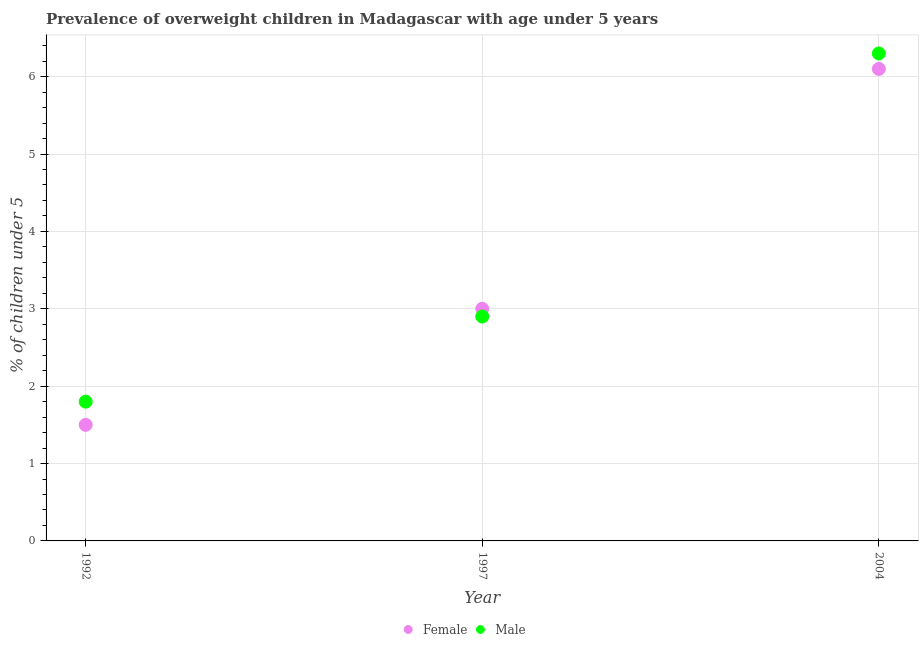How many different coloured dotlines are there?
Ensure brevity in your answer.  2. Is the number of dotlines equal to the number of legend labels?
Provide a short and direct response. Yes. What is the percentage of obese male children in 1997?
Give a very brief answer. 2.9. Across all years, what is the maximum percentage of obese female children?
Make the answer very short. 6.1. Across all years, what is the minimum percentage of obese female children?
Your response must be concise. 1.5. In which year was the percentage of obese male children minimum?
Give a very brief answer. 1992. What is the total percentage of obese male children in the graph?
Give a very brief answer. 11. What is the difference between the percentage of obese male children in 1992 and that in 2004?
Keep it short and to the point. -4.5. What is the difference between the percentage of obese male children in 1997 and the percentage of obese female children in 1992?
Ensure brevity in your answer.  1.4. What is the average percentage of obese female children per year?
Make the answer very short. 3.53. In the year 1992, what is the difference between the percentage of obese female children and percentage of obese male children?
Give a very brief answer. -0.3. What is the ratio of the percentage of obese female children in 1992 to that in 2004?
Keep it short and to the point. 0.25. Is the percentage of obese male children in 1992 less than that in 1997?
Offer a terse response. Yes. Is the difference between the percentage of obese female children in 1992 and 2004 greater than the difference between the percentage of obese male children in 1992 and 2004?
Your answer should be compact. No. What is the difference between the highest and the second highest percentage of obese male children?
Your answer should be very brief. 3.4. What is the difference between the highest and the lowest percentage of obese female children?
Offer a terse response. 4.6. In how many years, is the percentage of obese male children greater than the average percentage of obese male children taken over all years?
Your answer should be compact. 1. Does the percentage of obese male children monotonically increase over the years?
Make the answer very short. Yes. How many dotlines are there?
Provide a short and direct response. 2. Are the values on the major ticks of Y-axis written in scientific E-notation?
Your answer should be very brief. No. Does the graph contain any zero values?
Offer a very short reply. No. Does the graph contain grids?
Ensure brevity in your answer.  Yes. How are the legend labels stacked?
Offer a very short reply. Horizontal. What is the title of the graph?
Ensure brevity in your answer.  Prevalence of overweight children in Madagascar with age under 5 years. Does "International Visitors" appear as one of the legend labels in the graph?
Provide a succinct answer. No. What is the label or title of the Y-axis?
Make the answer very short.  % of children under 5. What is the  % of children under 5 of Male in 1992?
Give a very brief answer. 1.8. What is the  % of children under 5 of Female in 1997?
Provide a short and direct response. 3. What is the  % of children under 5 of Male in 1997?
Your answer should be compact. 2.9. What is the  % of children under 5 of Female in 2004?
Your answer should be very brief. 6.1. What is the  % of children under 5 of Male in 2004?
Your response must be concise. 6.3. Across all years, what is the maximum  % of children under 5 of Female?
Give a very brief answer. 6.1. Across all years, what is the maximum  % of children under 5 in Male?
Keep it short and to the point. 6.3. Across all years, what is the minimum  % of children under 5 in Female?
Provide a short and direct response. 1.5. Across all years, what is the minimum  % of children under 5 in Male?
Your answer should be very brief. 1.8. What is the total  % of children under 5 of Female in the graph?
Ensure brevity in your answer.  10.6. What is the difference between the  % of children under 5 in Female in 1992 and that in 1997?
Your answer should be very brief. -1.5. What is the difference between the  % of children under 5 of Male in 1992 and that in 1997?
Offer a very short reply. -1.1. What is the difference between the  % of children under 5 in Female in 1992 and that in 2004?
Make the answer very short. -4.6. What is the difference between the  % of children under 5 of Female in 1992 and the  % of children under 5 of Male in 2004?
Your answer should be compact. -4.8. What is the difference between the  % of children under 5 in Female in 1997 and the  % of children under 5 in Male in 2004?
Your answer should be compact. -3.3. What is the average  % of children under 5 in Female per year?
Give a very brief answer. 3.53. What is the average  % of children under 5 in Male per year?
Your answer should be compact. 3.67. In the year 1997, what is the difference between the  % of children under 5 in Female and  % of children under 5 in Male?
Keep it short and to the point. 0.1. What is the ratio of the  % of children under 5 of Male in 1992 to that in 1997?
Your response must be concise. 0.62. What is the ratio of the  % of children under 5 of Female in 1992 to that in 2004?
Give a very brief answer. 0.25. What is the ratio of the  % of children under 5 in Male in 1992 to that in 2004?
Make the answer very short. 0.29. What is the ratio of the  % of children under 5 of Female in 1997 to that in 2004?
Provide a succinct answer. 0.49. What is the ratio of the  % of children under 5 of Male in 1997 to that in 2004?
Offer a very short reply. 0.46. What is the difference between the highest and the second highest  % of children under 5 of Male?
Your answer should be very brief. 3.4. What is the difference between the highest and the lowest  % of children under 5 in Male?
Provide a succinct answer. 4.5. 